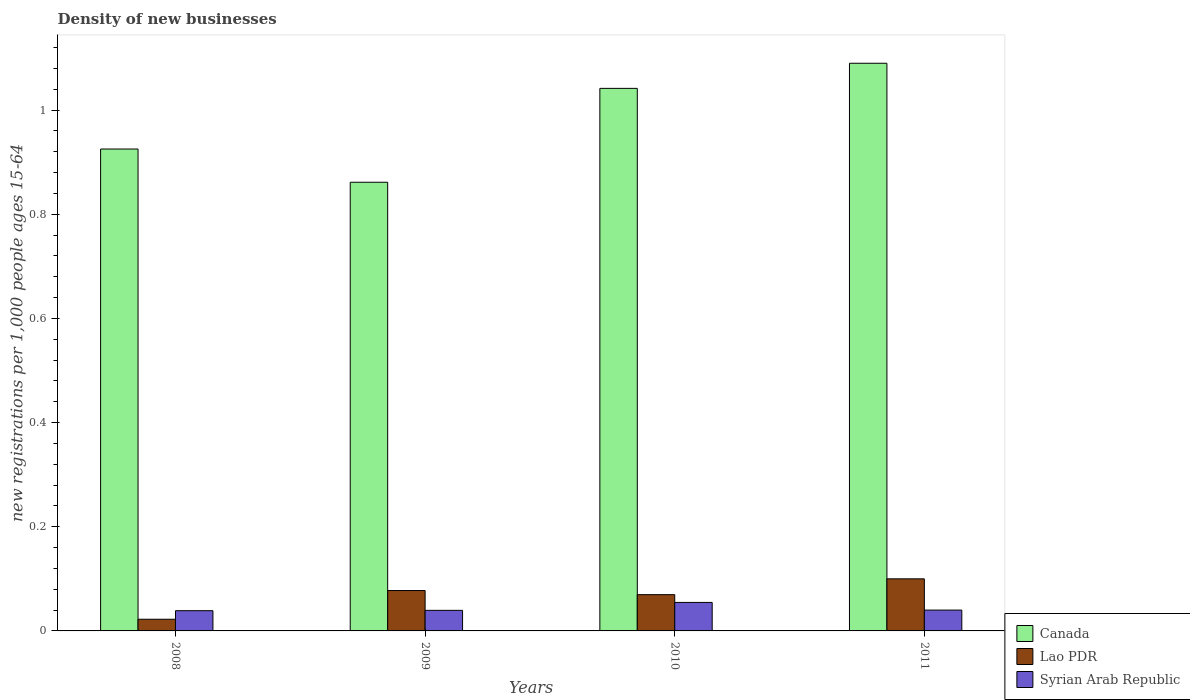How many different coloured bars are there?
Offer a terse response. 3. Are the number of bars on each tick of the X-axis equal?
Offer a terse response. Yes. How many bars are there on the 2nd tick from the left?
Ensure brevity in your answer.  3. What is the label of the 3rd group of bars from the left?
Ensure brevity in your answer.  2010. In how many cases, is the number of bars for a given year not equal to the number of legend labels?
Provide a succinct answer. 0. What is the number of new registrations in Syrian Arab Republic in 2008?
Offer a very short reply. 0.04. Across all years, what is the maximum number of new registrations in Canada?
Your response must be concise. 1.09. Across all years, what is the minimum number of new registrations in Syrian Arab Republic?
Provide a succinct answer. 0.04. In which year was the number of new registrations in Syrian Arab Republic maximum?
Offer a terse response. 2010. In which year was the number of new registrations in Lao PDR minimum?
Your response must be concise. 2008. What is the total number of new registrations in Syrian Arab Republic in the graph?
Your answer should be very brief. 0.17. What is the difference between the number of new registrations in Syrian Arab Republic in 2008 and that in 2011?
Keep it short and to the point. -0. What is the difference between the number of new registrations in Syrian Arab Republic in 2011 and the number of new registrations in Lao PDR in 2008?
Provide a short and direct response. 0.02. What is the average number of new registrations in Lao PDR per year?
Provide a short and direct response. 0.07. In the year 2010, what is the difference between the number of new registrations in Lao PDR and number of new registrations in Canada?
Provide a succinct answer. -0.97. What is the ratio of the number of new registrations in Syrian Arab Republic in 2008 to that in 2010?
Make the answer very short. 0.71. Is the number of new registrations in Syrian Arab Republic in 2008 less than that in 2010?
Provide a succinct answer. Yes. What is the difference between the highest and the second highest number of new registrations in Lao PDR?
Your answer should be compact. 0.02. What is the difference between the highest and the lowest number of new registrations in Syrian Arab Republic?
Make the answer very short. 0.02. In how many years, is the number of new registrations in Canada greater than the average number of new registrations in Canada taken over all years?
Your answer should be very brief. 2. What does the 1st bar from the left in 2011 represents?
Provide a short and direct response. Canada. What does the 1st bar from the right in 2009 represents?
Your response must be concise. Syrian Arab Republic. What is the difference between two consecutive major ticks on the Y-axis?
Offer a terse response. 0.2. Does the graph contain grids?
Provide a succinct answer. No. Where does the legend appear in the graph?
Keep it short and to the point. Bottom right. How many legend labels are there?
Keep it short and to the point. 3. How are the legend labels stacked?
Provide a succinct answer. Vertical. What is the title of the graph?
Give a very brief answer. Density of new businesses. What is the label or title of the X-axis?
Offer a very short reply. Years. What is the label or title of the Y-axis?
Offer a very short reply. New registrations per 1,0 people ages 15-64. What is the new registrations per 1,000 people ages 15-64 in Canada in 2008?
Your answer should be compact. 0.93. What is the new registrations per 1,000 people ages 15-64 of Lao PDR in 2008?
Your answer should be compact. 0.02. What is the new registrations per 1,000 people ages 15-64 of Syrian Arab Republic in 2008?
Keep it short and to the point. 0.04. What is the new registrations per 1,000 people ages 15-64 in Canada in 2009?
Offer a terse response. 0.86. What is the new registrations per 1,000 people ages 15-64 of Lao PDR in 2009?
Offer a terse response. 0.08. What is the new registrations per 1,000 people ages 15-64 of Syrian Arab Republic in 2009?
Offer a very short reply. 0.04. What is the new registrations per 1,000 people ages 15-64 of Canada in 2010?
Make the answer very short. 1.04. What is the new registrations per 1,000 people ages 15-64 in Lao PDR in 2010?
Your answer should be compact. 0.07. What is the new registrations per 1,000 people ages 15-64 in Syrian Arab Republic in 2010?
Make the answer very short. 0.05. What is the new registrations per 1,000 people ages 15-64 of Canada in 2011?
Keep it short and to the point. 1.09. What is the new registrations per 1,000 people ages 15-64 in Lao PDR in 2011?
Make the answer very short. 0.1. What is the new registrations per 1,000 people ages 15-64 of Syrian Arab Republic in 2011?
Your answer should be compact. 0.04. Across all years, what is the maximum new registrations per 1,000 people ages 15-64 in Canada?
Provide a succinct answer. 1.09. Across all years, what is the maximum new registrations per 1,000 people ages 15-64 of Lao PDR?
Offer a terse response. 0.1. Across all years, what is the maximum new registrations per 1,000 people ages 15-64 in Syrian Arab Republic?
Your answer should be very brief. 0.05. Across all years, what is the minimum new registrations per 1,000 people ages 15-64 in Canada?
Offer a very short reply. 0.86. Across all years, what is the minimum new registrations per 1,000 people ages 15-64 of Lao PDR?
Give a very brief answer. 0.02. Across all years, what is the minimum new registrations per 1,000 people ages 15-64 in Syrian Arab Republic?
Your response must be concise. 0.04. What is the total new registrations per 1,000 people ages 15-64 of Canada in the graph?
Your response must be concise. 3.92. What is the total new registrations per 1,000 people ages 15-64 in Lao PDR in the graph?
Keep it short and to the point. 0.27. What is the total new registrations per 1,000 people ages 15-64 in Syrian Arab Republic in the graph?
Keep it short and to the point. 0.17. What is the difference between the new registrations per 1,000 people ages 15-64 of Canada in 2008 and that in 2009?
Keep it short and to the point. 0.06. What is the difference between the new registrations per 1,000 people ages 15-64 in Lao PDR in 2008 and that in 2009?
Ensure brevity in your answer.  -0.06. What is the difference between the new registrations per 1,000 people ages 15-64 of Syrian Arab Republic in 2008 and that in 2009?
Your response must be concise. -0. What is the difference between the new registrations per 1,000 people ages 15-64 of Canada in 2008 and that in 2010?
Offer a very short reply. -0.12. What is the difference between the new registrations per 1,000 people ages 15-64 in Lao PDR in 2008 and that in 2010?
Give a very brief answer. -0.05. What is the difference between the new registrations per 1,000 people ages 15-64 in Syrian Arab Republic in 2008 and that in 2010?
Offer a very short reply. -0.02. What is the difference between the new registrations per 1,000 people ages 15-64 of Canada in 2008 and that in 2011?
Offer a very short reply. -0.16. What is the difference between the new registrations per 1,000 people ages 15-64 of Lao PDR in 2008 and that in 2011?
Your response must be concise. -0.08. What is the difference between the new registrations per 1,000 people ages 15-64 of Syrian Arab Republic in 2008 and that in 2011?
Offer a very short reply. -0. What is the difference between the new registrations per 1,000 people ages 15-64 in Canada in 2009 and that in 2010?
Make the answer very short. -0.18. What is the difference between the new registrations per 1,000 people ages 15-64 of Lao PDR in 2009 and that in 2010?
Make the answer very short. 0.01. What is the difference between the new registrations per 1,000 people ages 15-64 in Syrian Arab Republic in 2009 and that in 2010?
Provide a succinct answer. -0.02. What is the difference between the new registrations per 1,000 people ages 15-64 in Canada in 2009 and that in 2011?
Your answer should be very brief. -0.23. What is the difference between the new registrations per 1,000 people ages 15-64 of Lao PDR in 2009 and that in 2011?
Offer a terse response. -0.02. What is the difference between the new registrations per 1,000 people ages 15-64 in Syrian Arab Republic in 2009 and that in 2011?
Give a very brief answer. -0. What is the difference between the new registrations per 1,000 people ages 15-64 in Canada in 2010 and that in 2011?
Your answer should be very brief. -0.05. What is the difference between the new registrations per 1,000 people ages 15-64 in Lao PDR in 2010 and that in 2011?
Give a very brief answer. -0.03. What is the difference between the new registrations per 1,000 people ages 15-64 in Syrian Arab Republic in 2010 and that in 2011?
Provide a succinct answer. 0.01. What is the difference between the new registrations per 1,000 people ages 15-64 in Canada in 2008 and the new registrations per 1,000 people ages 15-64 in Lao PDR in 2009?
Keep it short and to the point. 0.85. What is the difference between the new registrations per 1,000 people ages 15-64 of Canada in 2008 and the new registrations per 1,000 people ages 15-64 of Syrian Arab Republic in 2009?
Provide a succinct answer. 0.89. What is the difference between the new registrations per 1,000 people ages 15-64 of Lao PDR in 2008 and the new registrations per 1,000 people ages 15-64 of Syrian Arab Republic in 2009?
Your answer should be very brief. -0.02. What is the difference between the new registrations per 1,000 people ages 15-64 in Canada in 2008 and the new registrations per 1,000 people ages 15-64 in Lao PDR in 2010?
Your response must be concise. 0.86. What is the difference between the new registrations per 1,000 people ages 15-64 in Canada in 2008 and the new registrations per 1,000 people ages 15-64 in Syrian Arab Republic in 2010?
Offer a very short reply. 0.87. What is the difference between the new registrations per 1,000 people ages 15-64 in Lao PDR in 2008 and the new registrations per 1,000 people ages 15-64 in Syrian Arab Republic in 2010?
Your answer should be very brief. -0.03. What is the difference between the new registrations per 1,000 people ages 15-64 in Canada in 2008 and the new registrations per 1,000 people ages 15-64 in Lao PDR in 2011?
Provide a short and direct response. 0.83. What is the difference between the new registrations per 1,000 people ages 15-64 in Canada in 2008 and the new registrations per 1,000 people ages 15-64 in Syrian Arab Republic in 2011?
Your answer should be compact. 0.89. What is the difference between the new registrations per 1,000 people ages 15-64 in Lao PDR in 2008 and the new registrations per 1,000 people ages 15-64 in Syrian Arab Republic in 2011?
Offer a terse response. -0.02. What is the difference between the new registrations per 1,000 people ages 15-64 in Canada in 2009 and the new registrations per 1,000 people ages 15-64 in Lao PDR in 2010?
Your answer should be very brief. 0.79. What is the difference between the new registrations per 1,000 people ages 15-64 in Canada in 2009 and the new registrations per 1,000 people ages 15-64 in Syrian Arab Republic in 2010?
Make the answer very short. 0.81. What is the difference between the new registrations per 1,000 people ages 15-64 in Lao PDR in 2009 and the new registrations per 1,000 people ages 15-64 in Syrian Arab Republic in 2010?
Make the answer very short. 0.02. What is the difference between the new registrations per 1,000 people ages 15-64 in Canada in 2009 and the new registrations per 1,000 people ages 15-64 in Lao PDR in 2011?
Your answer should be compact. 0.76. What is the difference between the new registrations per 1,000 people ages 15-64 in Canada in 2009 and the new registrations per 1,000 people ages 15-64 in Syrian Arab Republic in 2011?
Provide a short and direct response. 0.82. What is the difference between the new registrations per 1,000 people ages 15-64 of Lao PDR in 2009 and the new registrations per 1,000 people ages 15-64 of Syrian Arab Republic in 2011?
Offer a very short reply. 0.04. What is the difference between the new registrations per 1,000 people ages 15-64 in Canada in 2010 and the new registrations per 1,000 people ages 15-64 in Lao PDR in 2011?
Give a very brief answer. 0.94. What is the difference between the new registrations per 1,000 people ages 15-64 of Canada in 2010 and the new registrations per 1,000 people ages 15-64 of Syrian Arab Republic in 2011?
Provide a short and direct response. 1. What is the difference between the new registrations per 1,000 people ages 15-64 of Lao PDR in 2010 and the new registrations per 1,000 people ages 15-64 of Syrian Arab Republic in 2011?
Give a very brief answer. 0.03. What is the average new registrations per 1,000 people ages 15-64 in Canada per year?
Offer a very short reply. 0.98. What is the average new registrations per 1,000 people ages 15-64 of Lao PDR per year?
Keep it short and to the point. 0.07. What is the average new registrations per 1,000 people ages 15-64 in Syrian Arab Republic per year?
Make the answer very short. 0.04. In the year 2008, what is the difference between the new registrations per 1,000 people ages 15-64 of Canada and new registrations per 1,000 people ages 15-64 of Lao PDR?
Your response must be concise. 0.9. In the year 2008, what is the difference between the new registrations per 1,000 people ages 15-64 in Canada and new registrations per 1,000 people ages 15-64 in Syrian Arab Republic?
Offer a terse response. 0.89. In the year 2008, what is the difference between the new registrations per 1,000 people ages 15-64 in Lao PDR and new registrations per 1,000 people ages 15-64 in Syrian Arab Republic?
Offer a terse response. -0.02. In the year 2009, what is the difference between the new registrations per 1,000 people ages 15-64 in Canada and new registrations per 1,000 people ages 15-64 in Lao PDR?
Keep it short and to the point. 0.78. In the year 2009, what is the difference between the new registrations per 1,000 people ages 15-64 of Canada and new registrations per 1,000 people ages 15-64 of Syrian Arab Republic?
Offer a very short reply. 0.82. In the year 2009, what is the difference between the new registrations per 1,000 people ages 15-64 of Lao PDR and new registrations per 1,000 people ages 15-64 of Syrian Arab Republic?
Offer a terse response. 0.04. In the year 2010, what is the difference between the new registrations per 1,000 people ages 15-64 of Canada and new registrations per 1,000 people ages 15-64 of Lao PDR?
Provide a short and direct response. 0.97. In the year 2010, what is the difference between the new registrations per 1,000 people ages 15-64 in Canada and new registrations per 1,000 people ages 15-64 in Syrian Arab Republic?
Provide a short and direct response. 0.99. In the year 2010, what is the difference between the new registrations per 1,000 people ages 15-64 of Lao PDR and new registrations per 1,000 people ages 15-64 of Syrian Arab Republic?
Provide a succinct answer. 0.01. In the year 2011, what is the difference between the new registrations per 1,000 people ages 15-64 of Canada and new registrations per 1,000 people ages 15-64 of Syrian Arab Republic?
Offer a terse response. 1.05. In the year 2011, what is the difference between the new registrations per 1,000 people ages 15-64 of Lao PDR and new registrations per 1,000 people ages 15-64 of Syrian Arab Republic?
Your response must be concise. 0.06. What is the ratio of the new registrations per 1,000 people ages 15-64 of Canada in 2008 to that in 2009?
Offer a terse response. 1.07. What is the ratio of the new registrations per 1,000 people ages 15-64 in Lao PDR in 2008 to that in 2009?
Make the answer very short. 0.29. What is the ratio of the new registrations per 1,000 people ages 15-64 of Syrian Arab Republic in 2008 to that in 2009?
Ensure brevity in your answer.  0.98. What is the ratio of the new registrations per 1,000 people ages 15-64 in Canada in 2008 to that in 2010?
Offer a terse response. 0.89. What is the ratio of the new registrations per 1,000 people ages 15-64 in Lao PDR in 2008 to that in 2010?
Your response must be concise. 0.32. What is the ratio of the new registrations per 1,000 people ages 15-64 of Syrian Arab Republic in 2008 to that in 2010?
Offer a very short reply. 0.71. What is the ratio of the new registrations per 1,000 people ages 15-64 in Canada in 2008 to that in 2011?
Ensure brevity in your answer.  0.85. What is the ratio of the new registrations per 1,000 people ages 15-64 of Lao PDR in 2008 to that in 2011?
Keep it short and to the point. 0.22. What is the ratio of the new registrations per 1,000 people ages 15-64 in Syrian Arab Republic in 2008 to that in 2011?
Provide a short and direct response. 0.97. What is the ratio of the new registrations per 1,000 people ages 15-64 in Canada in 2009 to that in 2010?
Provide a succinct answer. 0.83. What is the ratio of the new registrations per 1,000 people ages 15-64 of Lao PDR in 2009 to that in 2010?
Your response must be concise. 1.11. What is the ratio of the new registrations per 1,000 people ages 15-64 in Syrian Arab Republic in 2009 to that in 2010?
Your response must be concise. 0.72. What is the ratio of the new registrations per 1,000 people ages 15-64 in Canada in 2009 to that in 2011?
Provide a succinct answer. 0.79. What is the ratio of the new registrations per 1,000 people ages 15-64 of Lao PDR in 2009 to that in 2011?
Provide a succinct answer. 0.78. What is the ratio of the new registrations per 1,000 people ages 15-64 in Syrian Arab Republic in 2009 to that in 2011?
Your answer should be compact. 0.99. What is the ratio of the new registrations per 1,000 people ages 15-64 of Canada in 2010 to that in 2011?
Provide a succinct answer. 0.96. What is the ratio of the new registrations per 1,000 people ages 15-64 of Lao PDR in 2010 to that in 2011?
Offer a very short reply. 0.7. What is the ratio of the new registrations per 1,000 people ages 15-64 in Syrian Arab Republic in 2010 to that in 2011?
Provide a short and direct response. 1.37. What is the difference between the highest and the second highest new registrations per 1,000 people ages 15-64 in Canada?
Provide a short and direct response. 0.05. What is the difference between the highest and the second highest new registrations per 1,000 people ages 15-64 of Lao PDR?
Your response must be concise. 0.02. What is the difference between the highest and the second highest new registrations per 1,000 people ages 15-64 in Syrian Arab Republic?
Keep it short and to the point. 0.01. What is the difference between the highest and the lowest new registrations per 1,000 people ages 15-64 in Canada?
Offer a very short reply. 0.23. What is the difference between the highest and the lowest new registrations per 1,000 people ages 15-64 in Lao PDR?
Provide a succinct answer. 0.08. What is the difference between the highest and the lowest new registrations per 1,000 people ages 15-64 in Syrian Arab Republic?
Provide a short and direct response. 0.02. 